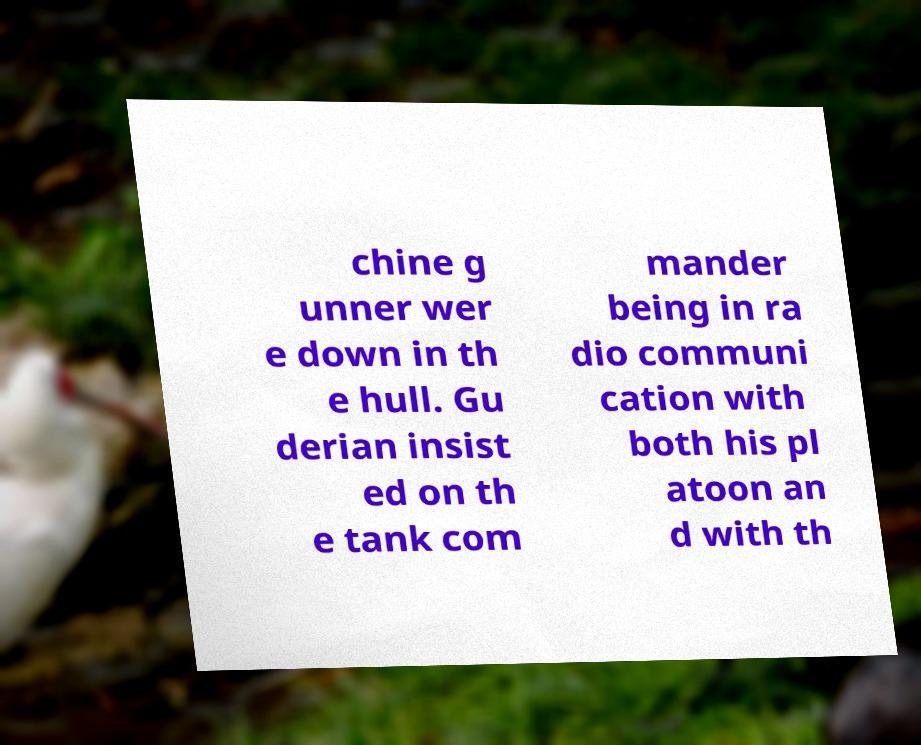Please read and relay the text visible in this image. What does it say? chine g unner wer e down in th e hull. Gu derian insist ed on th e tank com mander being in ra dio communi cation with both his pl atoon an d with th 